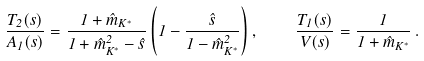Convert formula to latex. <formula><loc_0><loc_0><loc_500><loc_500>\frac { T _ { 2 } ( s ) } { A _ { 1 } ( s ) } = \frac { 1 + \hat { m } _ { K ^ { * } } } { 1 + \hat { m } _ { K ^ { * } } ^ { 2 } - \hat { s } } \left ( 1 - \frac { \hat { s } } { 1 - \hat { m } _ { K ^ { * } } ^ { 2 } } \right ) , \quad \frac { T _ { 1 } ( s ) } { V ( s ) } = \frac { 1 } { 1 + \hat { m } _ { K ^ { * } } } \, .</formula> 